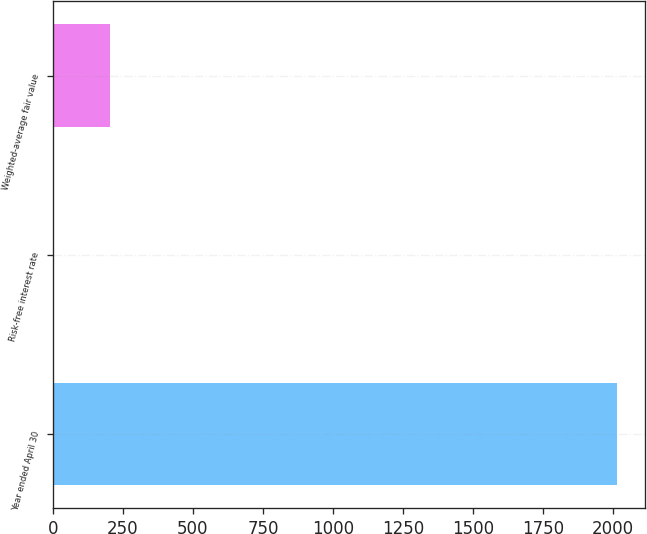Convert chart to OTSL. <chart><loc_0><loc_0><loc_500><loc_500><bar_chart><fcel>Year ended April 30<fcel>Risk-free interest rate<fcel>Weighted-average fair value<nl><fcel>2015<fcel>0.81<fcel>202.23<nl></chart> 